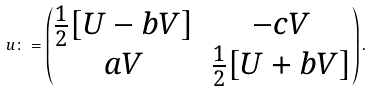Convert formula to latex. <formula><loc_0><loc_0><loc_500><loc_500>u \colon = \begin{pmatrix} \frac { 1 } { 2 } [ U - b V ] & - c V \\ a V & \frac { 1 } { 2 } [ U + b V ] \end{pmatrix} .</formula> 